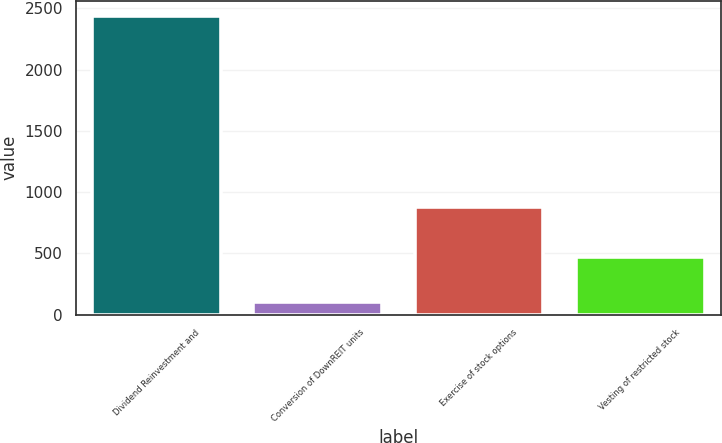Convert chart. <chart><loc_0><loc_0><loc_500><loc_500><bar_chart><fcel>Dividend Reinvestment and<fcel>Conversion of DownREIT units<fcel>Exercise of stock options<fcel>Vesting of restricted stock<nl><fcel>2441<fcel>100<fcel>876<fcel>471<nl></chart> 